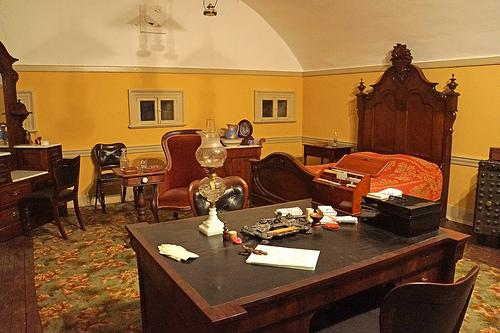Identify the main object in the image and explain a complex reasoning behind its presence. The main object is the bed with an orange bedspread and a large brown headboard, suggesting a central focus on comfort and aesthetics in the elegant bedroom design. Analyze the emotions conveyed by the elements in the image. The image reflects a cozy, comfortable, and warm atmosphere with its furniture and colors. Mention three things lying on the table in the image. Clear lamp, white papers, and a glass which appears to be colorless. Examine the floor details and mention the covering material and its design. The floor is wooden and covered with a gold and green flowered carpet. Based on the image, what kind of room do you think it is? The view is in a bedroom with an elegant setup and various ornaments. Count the number of chairs and windows present in the image. There are three chairs and two windows with white frames. Identify the color of the bedspread and describe the headboard on the bed. The bedspread is orange and the bed has a large brown headboard. Describe any visible interactions between the objects in the image. The papers seem to be left on the table, and the clear lamp on the table is reflecting light creating a shadow of the ceiling lantern on the wall. What material does the chair near the table seem to be made of? The chair appears to be made of wood and leather. Provide a brief description of the room's features in the image. A very elegant room with wooden furniture, a flowered area rug, and a dark yellow wall. Keep an eye out for a blue vase situated under the window. No, it's not mentioned in the image. Try to detect the antique clock hanging on the wall. This instruction is intended to mislead the viewer by describing a non-existent object in the image. Clocks are common items found on walls, especially in elegant rooms, so the viewer may be persuaded to search for it. The idea of an antique clock can also be intriguing, further convincing the viewer to look for it. Notice the glass chandelier hanging from the ceiling. The mention of a glass chandelier is deceptive because there's no object described as a chandelier in the image. The intended confusion lies in the mention of a ceiling lantern, which may make the reader think there could be a chandelier near it. Do you see the green plant positioned near the corner of the room? This instruction asks the viewer to locate a green plant that doesn't exist in the image. It's a typical decor item found in many rooms, which might add to the believability of its presence in the elegant space. Can you find the golden statue placed atop the fireplace? A golden statue atop a fireplace is a common luxury item found in fancy rooms, but it does not exist in this specific image. This instruction is meant to deceive by encouraging the viewer to look for an object that isn't there. 